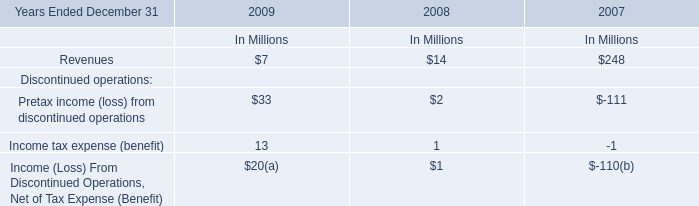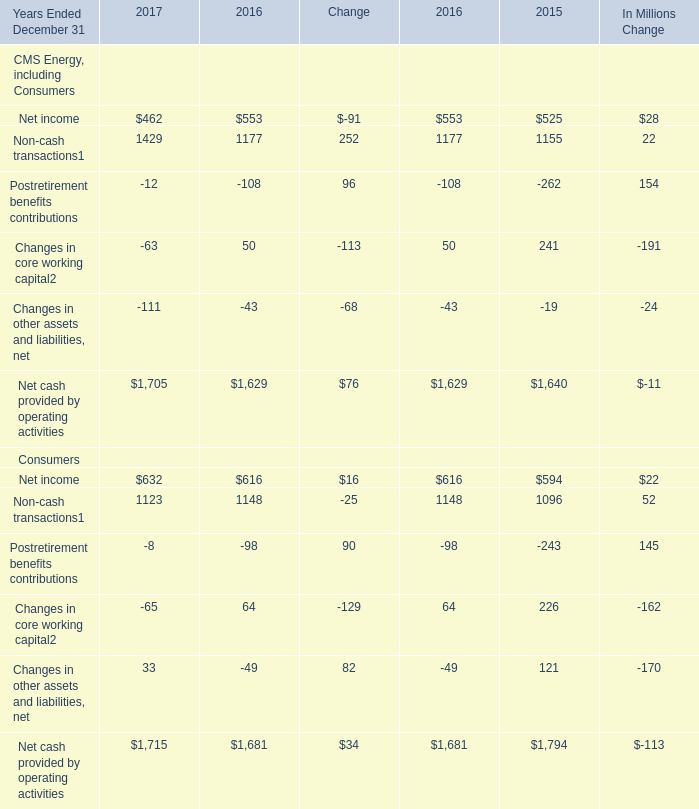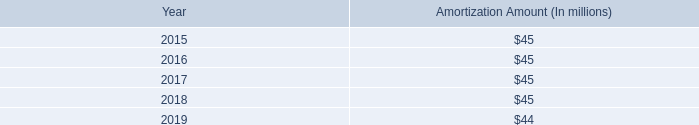What is the sum of Net income for CMS Energy, including Consumers in 2017 and Revenues 2009? (in million) 
Computations: (7 + 462)
Answer: 469.0. 